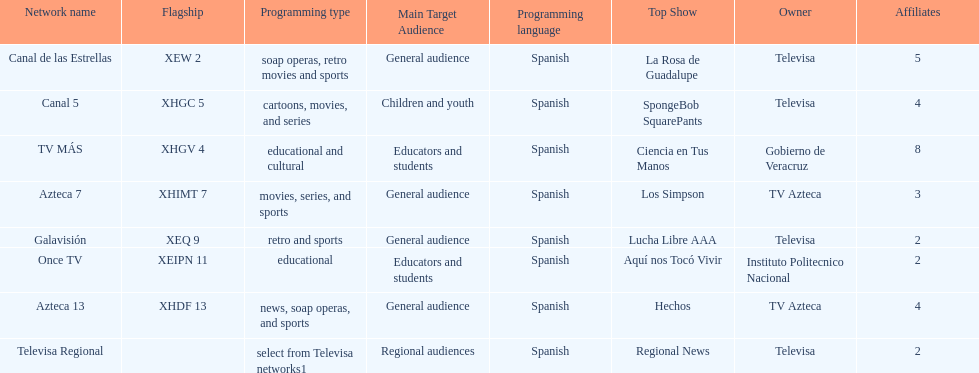How many networks have more affiliates than canal de las estrellas? 1. 